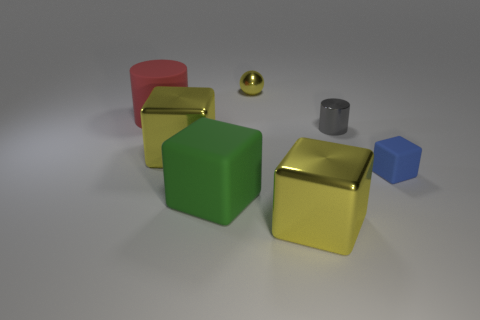How many shiny blocks have the same color as the tiny ball? 2 